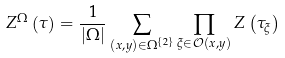<formula> <loc_0><loc_0><loc_500><loc_500>Z ^ { \Omega } \left ( \tau \right ) = \frac { 1 } { \left | \Omega \right | } \sum _ { \left ( x , y \right ) \in \Omega ^ { \left \{ 2 \right \} } } \prod _ { \xi \in \mathcal { O } ( x , y ) } Z \left ( \tau _ { \xi } \right )</formula> 